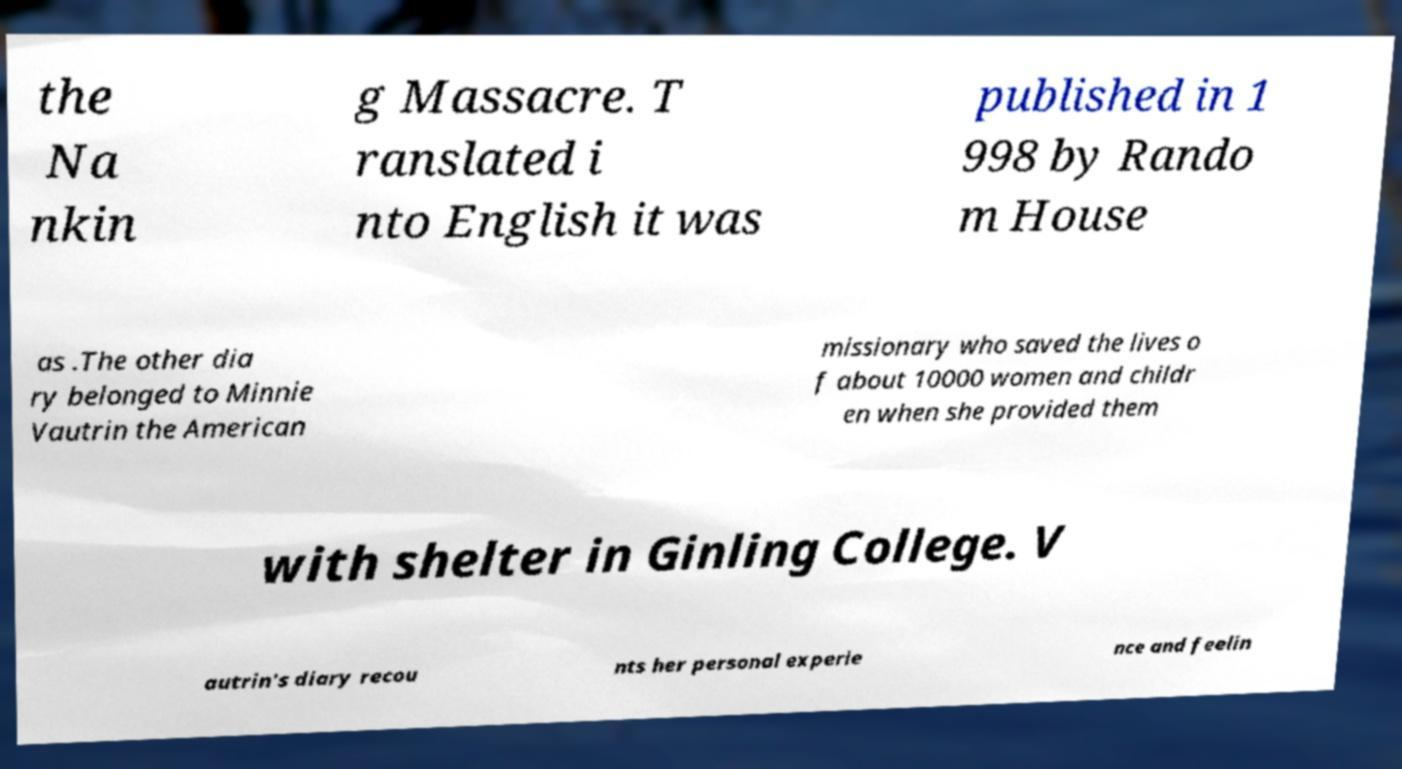Please read and relay the text visible in this image. What does it say? the Na nkin g Massacre. T ranslated i nto English it was published in 1 998 by Rando m House as .The other dia ry belonged to Minnie Vautrin the American missionary who saved the lives o f about 10000 women and childr en when she provided them with shelter in Ginling College. V autrin's diary recou nts her personal experie nce and feelin 